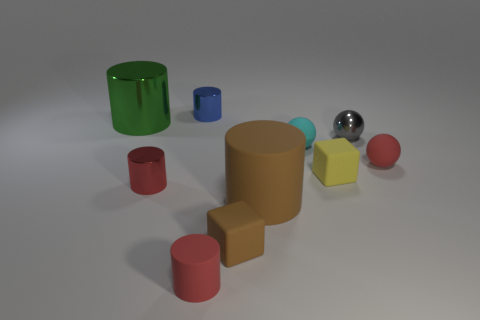Subtract all blue shiny cylinders. How many cylinders are left? 4 Subtract all green cylinders. How many cylinders are left? 4 Subtract all spheres. How many objects are left? 7 Subtract 1 cubes. How many cubes are left? 1 Subtract all small red cylinders. Subtract all yellow things. How many objects are left? 7 Add 9 green things. How many green things are left? 10 Add 8 small rubber blocks. How many small rubber blocks exist? 10 Subtract 0 blue blocks. How many objects are left? 10 Subtract all green blocks. Subtract all blue cylinders. How many blocks are left? 2 Subtract all green cubes. How many gray spheres are left? 1 